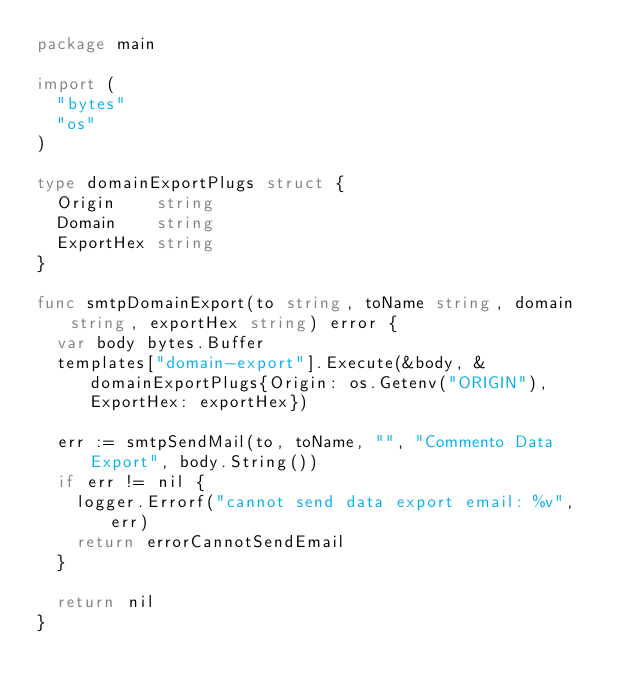Convert code to text. <code><loc_0><loc_0><loc_500><loc_500><_Go_>package main

import (
	"bytes"
	"os"
)

type domainExportPlugs struct {
	Origin    string
	Domain    string
	ExportHex string
}

func smtpDomainExport(to string, toName string, domain string, exportHex string) error {
	var body bytes.Buffer
	templates["domain-export"].Execute(&body, &domainExportPlugs{Origin: os.Getenv("ORIGIN"), ExportHex: exportHex})

	err := smtpSendMail(to, toName, "", "Commento Data Export", body.String())
	if err != nil {
		logger.Errorf("cannot send data export email: %v", err)
		return errorCannotSendEmail
	}

	return nil
}
</code> 